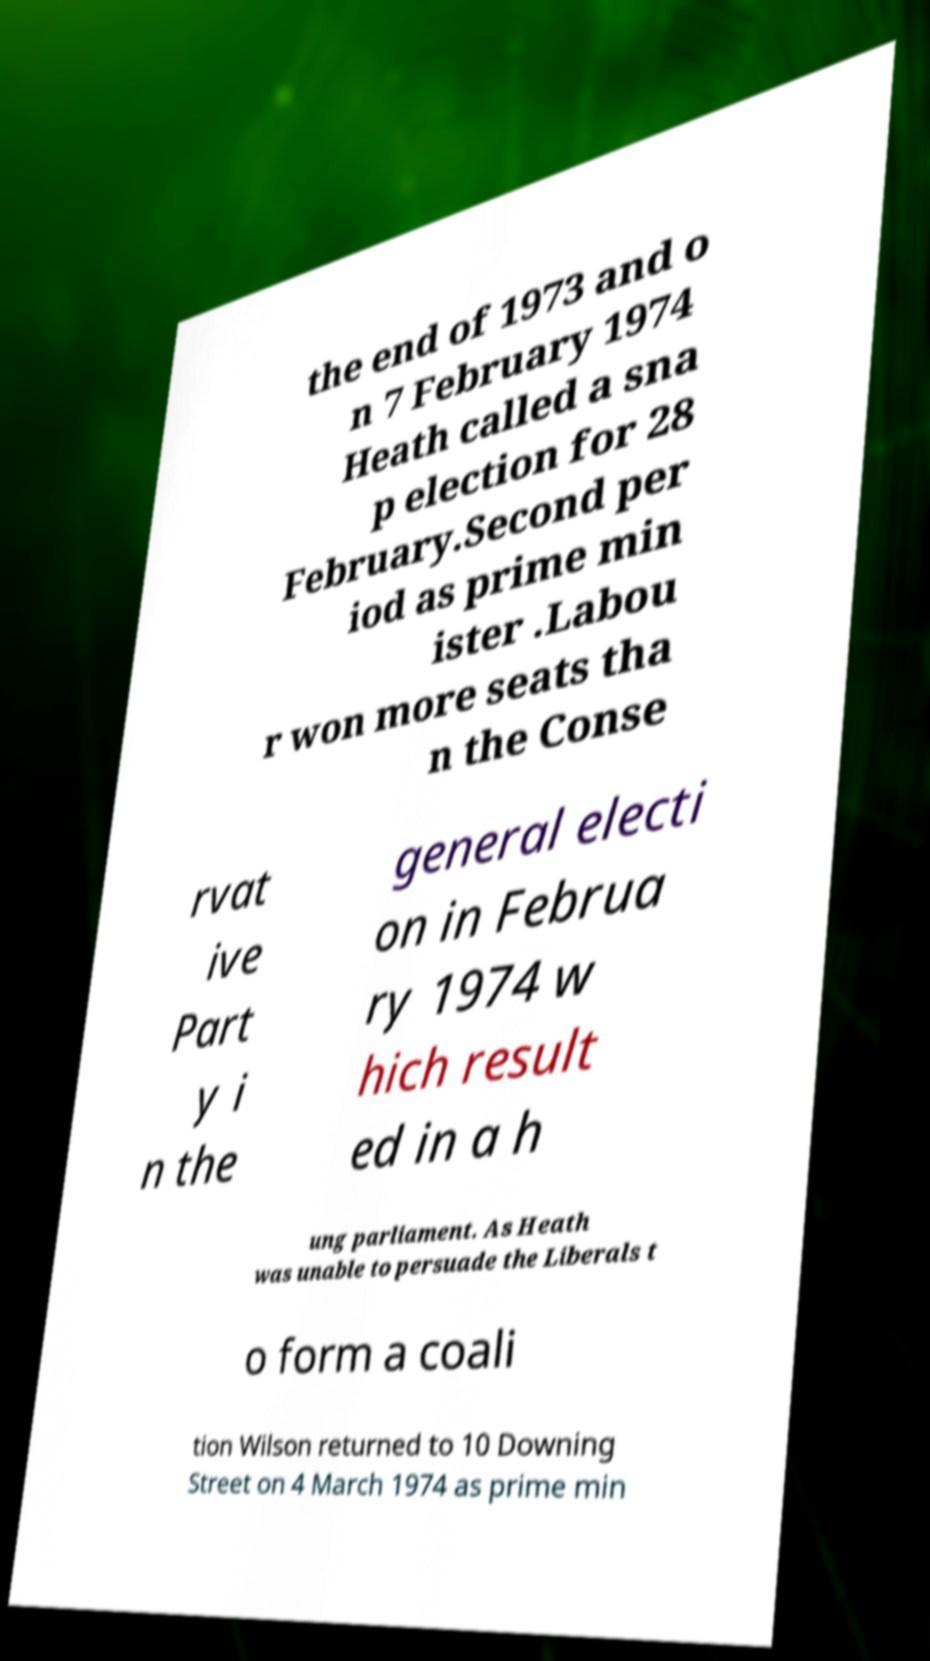There's text embedded in this image that I need extracted. Can you transcribe it verbatim? the end of 1973 and o n 7 February 1974 Heath called a sna p election for 28 February.Second per iod as prime min ister .Labou r won more seats tha n the Conse rvat ive Part y i n the general electi on in Februa ry 1974 w hich result ed in a h ung parliament. As Heath was unable to persuade the Liberals t o form a coali tion Wilson returned to 10 Downing Street on 4 March 1974 as prime min 